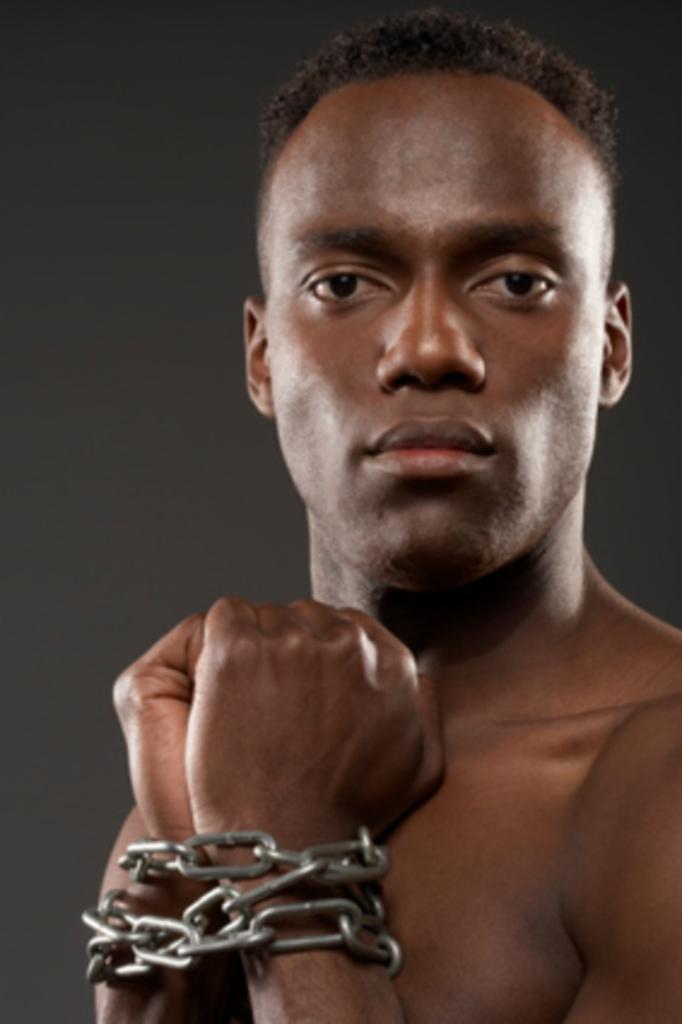In one or two sentences, can you explain what this image depicts? In this image I can see the person whose hands are tied with the metal chain. And there is a black background. 